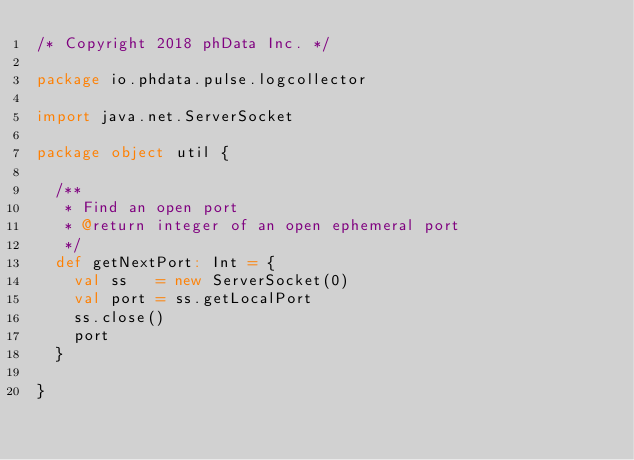<code> <loc_0><loc_0><loc_500><loc_500><_Scala_>/* Copyright 2018 phData Inc. */

package io.phdata.pulse.logcollector

import java.net.ServerSocket

package object util {

  /**
   * Find an open port
   * @return integer of an open ephemeral port
   */
  def getNextPort: Int = {
    val ss   = new ServerSocket(0)
    val port = ss.getLocalPort
    ss.close()
    port
  }

}
</code> 